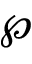Convert formula to latex. <formula><loc_0><loc_0><loc_500><loc_500>\wp</formula> 